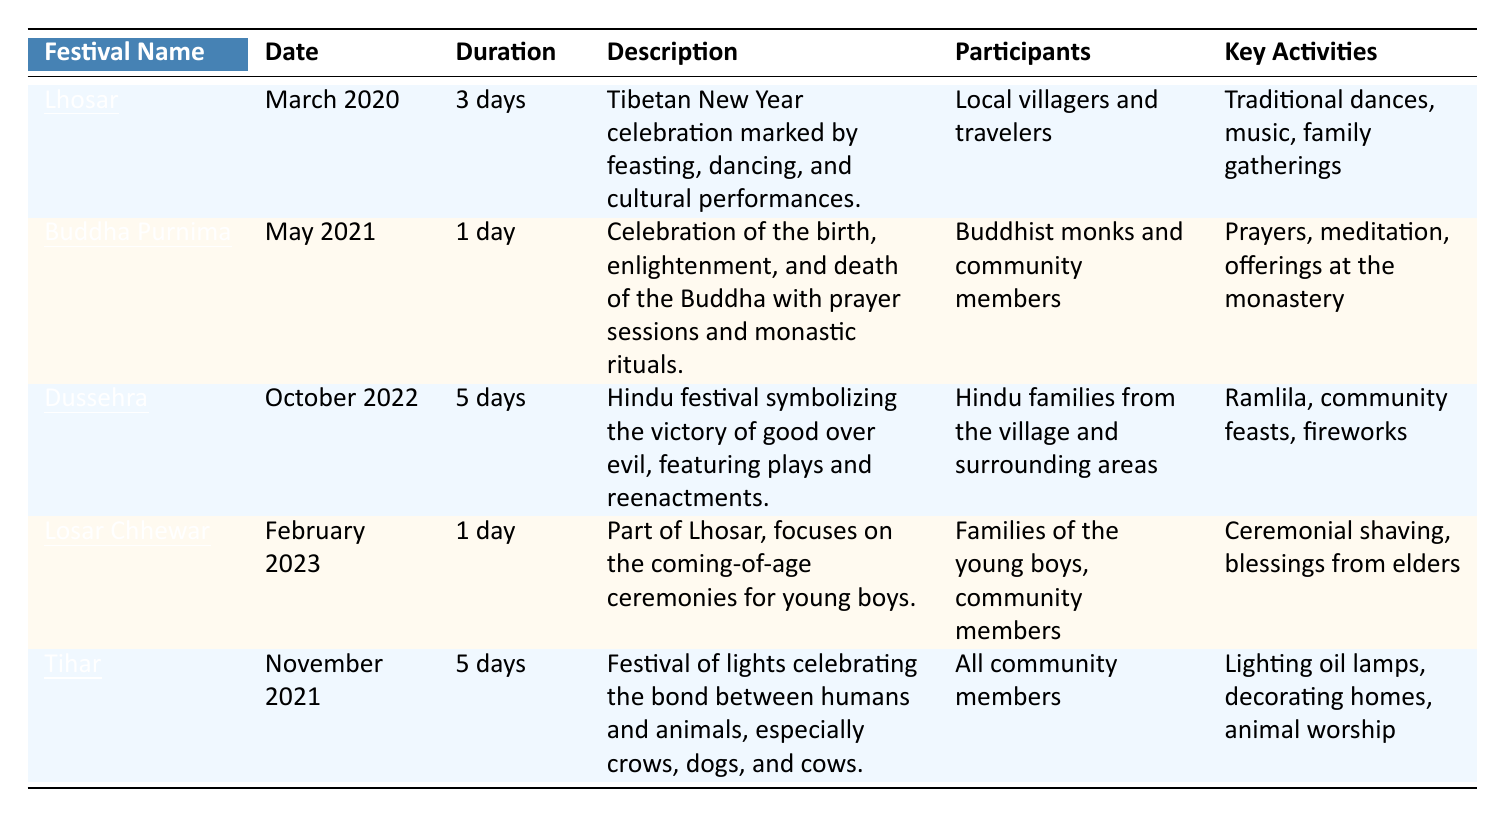What is the duration of the Tihar festival? The table indicates that the duration of the Tihar festival is listed as 5 days.
Answer: 5 days Which festival is celebrated in March 2020? According to the table, the festival celebrated in March 2020 is Lhosar.
Answer: Lhosar How many days does the Dussehra festival last? The Dussehra festival, as per the table, lasts for 5 days.
Answer: 5 days Was Buddha Purnima celebrated in the year 2021? The table shows that Buddha Purnima was indeed celebrated in May 2021.
Answer: Yes Which festivals involve community members as participants? The festivals that list community members as participants are Lhosar, Buddha Purnima, Tihar, and Losar Chhewar.
Answer: Lhosar, Buddha Purnima, Tihar, Losar Chhewar How many total days are celebrated across all festivals? We sum the durations of each festival: 3 (Lhosar) + 1 (Buddha Purnima) + 5 (Dussehra) + 1 (Losar Chhewar) + 5 (Tihar) = 15 days in total.
Answer: 15 days What key activity is common to both Lhosar and Tihar? The key activity that is common to Lhosar and Tihar is the celebration that involves community gatherings, dancing, and lighting lamps.
Answer: Community gatherings Is there any festival that lasts only one day? Yes, both Buddha Purnima and Losar Chhewar are festivals that last for one day, as specified in the table.
Answer: Yes Which festival has the most elaborate description? The Dussehra festival has a longer description compared to the others, detailing its significance and activities related to it.
Answer: Dussehra What are the key activities for the festival held in February 2023? The key activities for the Losar Chhewar festival include ceremonial shaving and blessings from elders, as shown in the table.
Answer: Ceremonial shaving, blessings from elders 